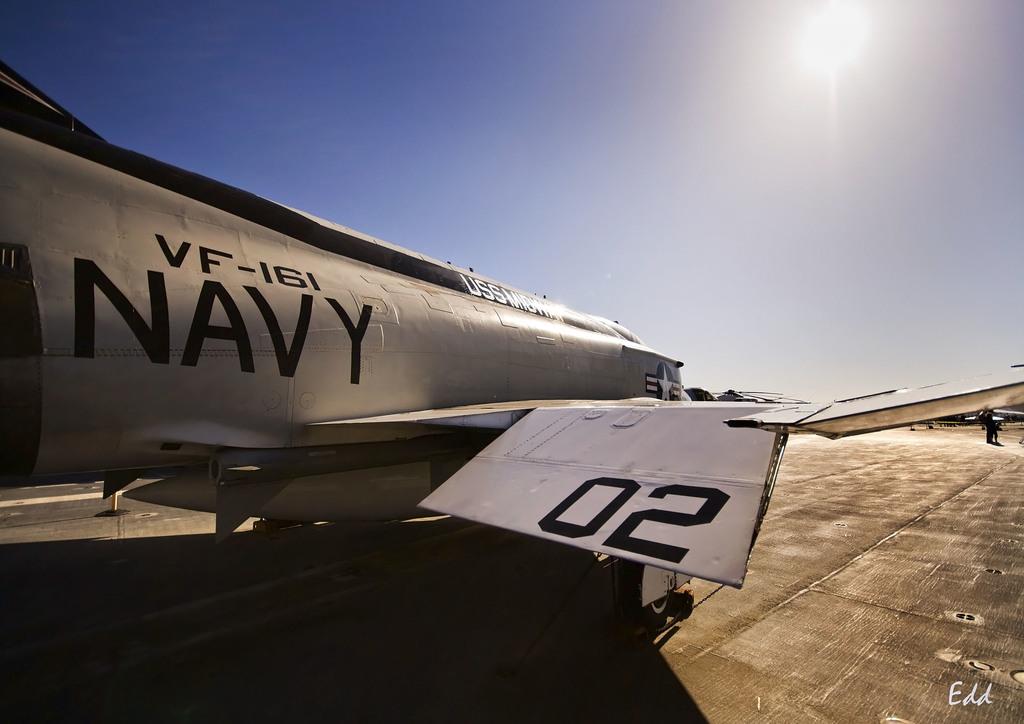What type of plane is this?
Your answer should be very brief. Vf-161. 